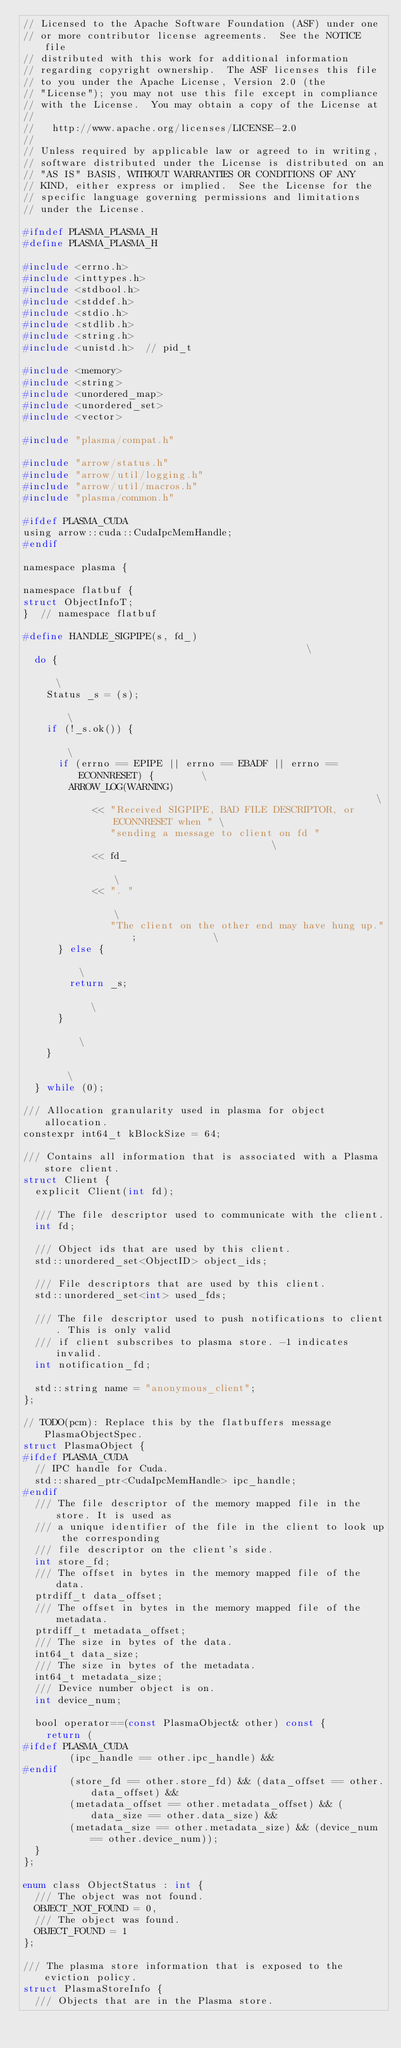Convert code to text. <code><loc_0><loc_0><loc_500><loc_500><_C_>// Licensed to the Apache Software Foundation (ASF) under one
// or more contributor license agreements.  See the NOTICE file
// distributed with this work for additional information
// regarding copyright ownership.  The ASF licenses this file
// to you under the Apache License, Version 2.0 (the
// "License"); you may not use this file except in compliance
// with the License.  You may obtain a copy of the License at
//
//   http://www.apache.org/licenses/LICENSE-2.0
//
// Unless required by applicable law or agreed to in writing,
// software distributed under the License is distributed on an
// "AS IS" BASIS, WITHOUT WARRANTIES OR CONDITIONS OF ANY
// KIND, either express or implied.  See the License for the
// specific language governing permissions and limitations
// under the License.

#ifndef PLASMA_PLASMA_H
#define PLASMA_PLASMA_H

#include <errno.h>
#include <inttypes.h>
#include <stdbool.h>
#include <stddef.h>
#include <stdio.h>
#include <stdlib.h>
#include <string.h>
#include <unistd.h>  // pid_t

#include <memory>
#include <string>
#include <unordered_map>
#include <unordered_set>
#include <vector>

#include "plasma/compat.h"

#include "arrow/status.h"
#include "arrow/util/logging.h"
#include "arrow/util/macros.h"
#include "plasma/common.h"

#ifdef PLASMA_CUDA
using arrow::cuda::CudaIpcMemHandle;
#endif

namespace plasma {

namespace flatbuf {
struct ObjectInfoT;
}  // namespace flatbuf

#define HANDLE_SIGPIPE(s, fd_)                                              \
  do {                                                                      \
    Status _s = (s);                                                        \
    if (!_s.ok()) {                                                         \
      if (errno == EPIPE || errno == EBADF || errno == ECONNRESET) {        \
        ARROW_LOG(WARNING)                                                  \
            << "Received SIGPIPE, BAD FILE DESCRIPTOR, or ECONNRESET when " \
               "sending a message to client on fd "                         \
            << fd_                                                          \
            << ". "                                                         \
               "The client on the other end may have hung up.";             \
      } else {                                                              \
        return _s;                                                          \
      }                                                                     \
    }                                                                       \
  } while (0);

/// Allocation granularity used in plasma for object allocation.
constexpr int64_t kBlockSize = 64;

/// Contains all information that is associated with a Plasma store client.
struct Client {
  explicit Client(int fd);

  /// The file descriptor used to communicate with the client.
  int fd;

  /// Object ids that are used by this client.
  std::unordered_set<ObjectID> object_ids;

  /// File descriptors that are used by this client.
  std::unordered_set<int> used_fds;

  /// The file descriptor used to push notifications to client. This is only valid
  /// if client subscribes to plasma store. -1 indicates invalid.
  int notification_fd;

  std::string name = "anonymous_client";
};

// TODO(pcm): Replace this by the flatbuffers message PlasmaObjectSpec.
struct PlasmaObject {
#ifdef PLASMA_CUDA
  // IPC handle for Cuda.
  std::shared_ptr<CudaIpcMemHandle> ipc_handle;
#endif
  /// The file descriptor of the memory mapped file in the store. It is used as
  /// a unique identifier of the file in the client to look up the corresponding
  /// file descriptor on the client's side.
  int store_fd;
  /// The offset in bytes in the memory mapped file of the data.
  ptrdiff_t data_offset;
  /// The offset in bytes in the memory mapped file of the metadata.
  ptrdiff_t metadata_offset;
  /// The size in bytes of the data.
  int64_t data_size;
  /// The size in bytes of the metadata.
  int64_t metadata_size;
  /// Device number object is on.
  int device_num;

  bool operator==(const PlasmaObject& other) const {
    return (
#ifdef PLASMA_CUDA
        (ipc_handle == other.ipc_handle) &&
#endif
        (store_fd == other.store_fd) && (data_offset == other.data_offset) &&
        (metadata_offset == other.metadata_offset) && (data_size == other.data_size) &&
        (metadata_size == other.metadata_size) && (device_num == other.device_num));
  }
};

enum class ObjectStatus : int {
  /// The object was not found.
  OBJECT_NOT_FOUND = 0,
  /// The object was found.
  OBJECT_FOUND = 1
};

/// The plasma store information that is exposed to the eviction policy.
struct PlasmaStoreInfo {
  /// Objects that are in the Plasma store.</code> 